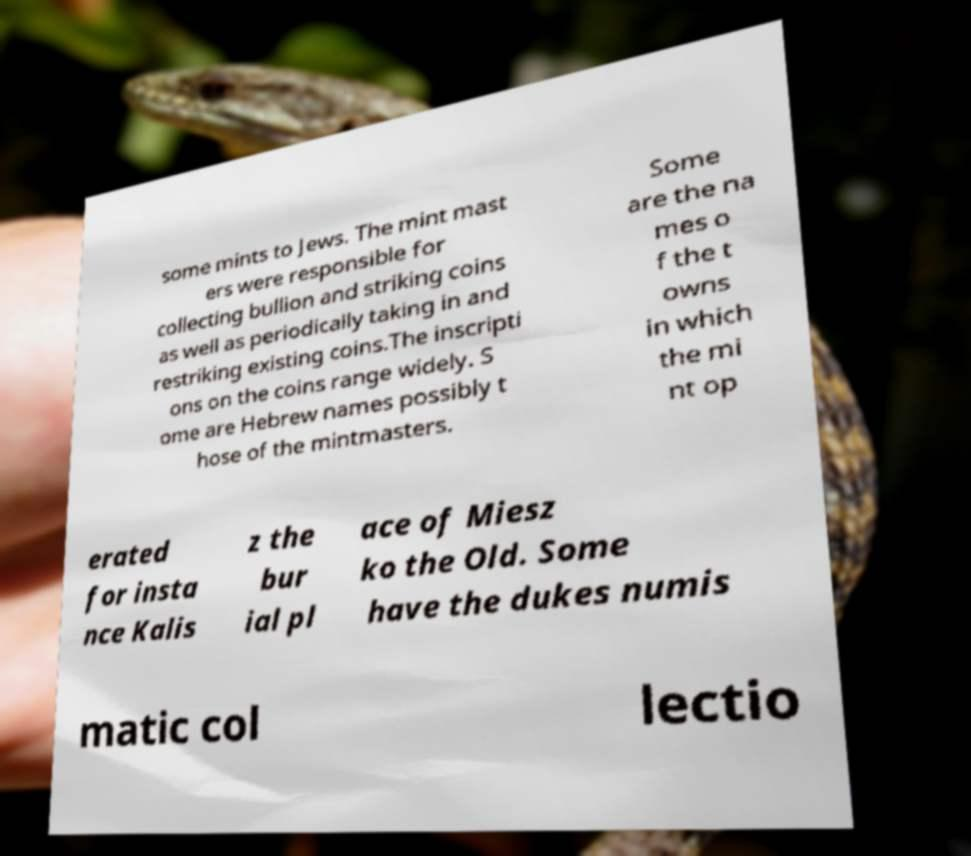For documentation purposes, I need the text within this image transcribed. Could you provide that? some mints to Jews. The mint mast ers were responsible for collecting bullion and striking coins as well as periodically taking in and restriking existing coins.The inscripti ons on the coins range widely. S ome are Hebrew names possibly t hose of the mintmasters. Some are the na mes o f the t owns in which the mi nt op erated for insta nce Kalis z the bur ial pl ace of Miesz ko the Old. Some have the dukes numis matic col lectio 